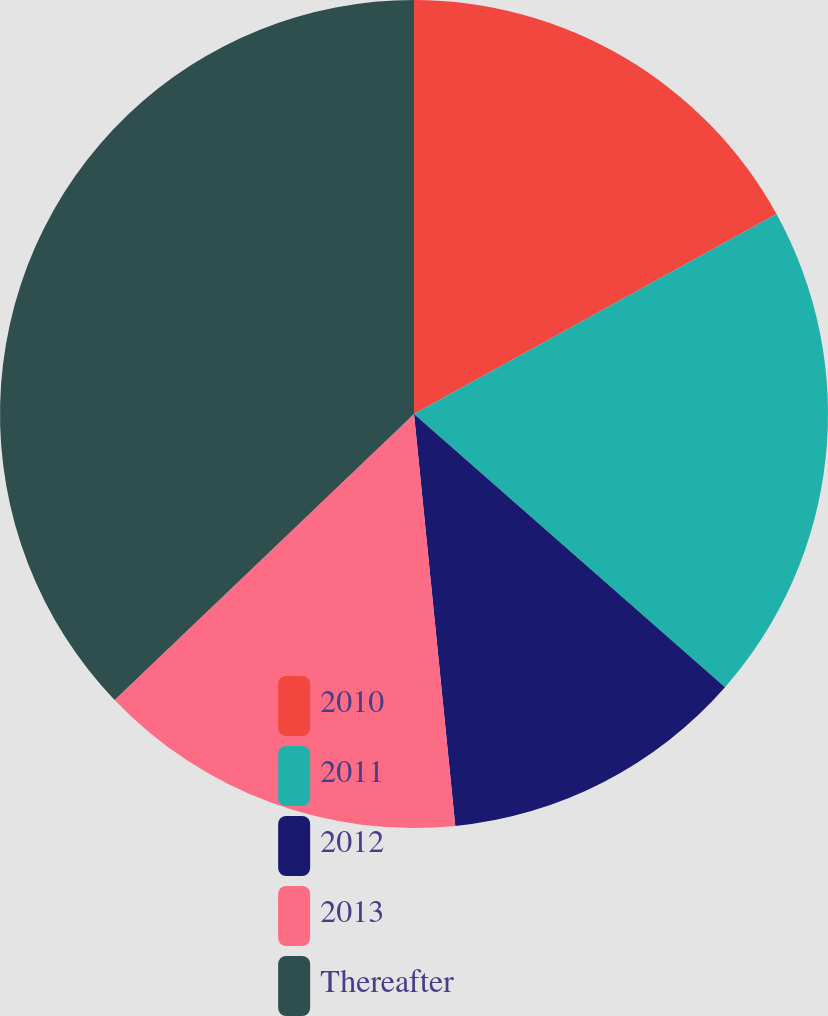Convert chart to OTSL. <chart><loc_0><loc_0><loc_500><loc_500><pie_chart><fcel>2010<fcel>2011<fcel>2012<fcel>2013<fcel>Thereafter<nl><fcel>16.98%<fcel>19.5%<fcel>11.94%<fcel>14.46%<fcel>37.14%<nl></chart> 